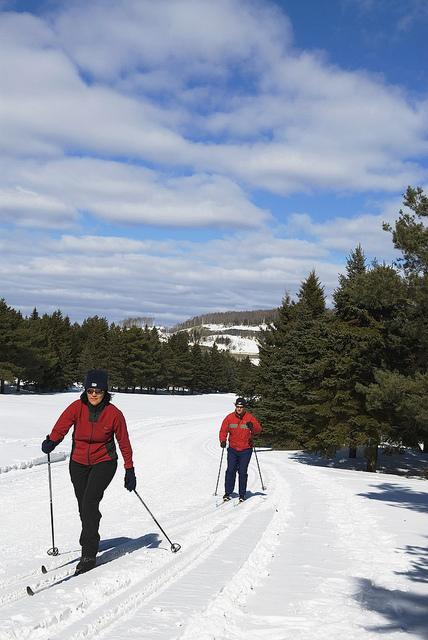What action are the people taking?

Choices:
A) falling
B) descend
C) riding
D) ascend ascend 